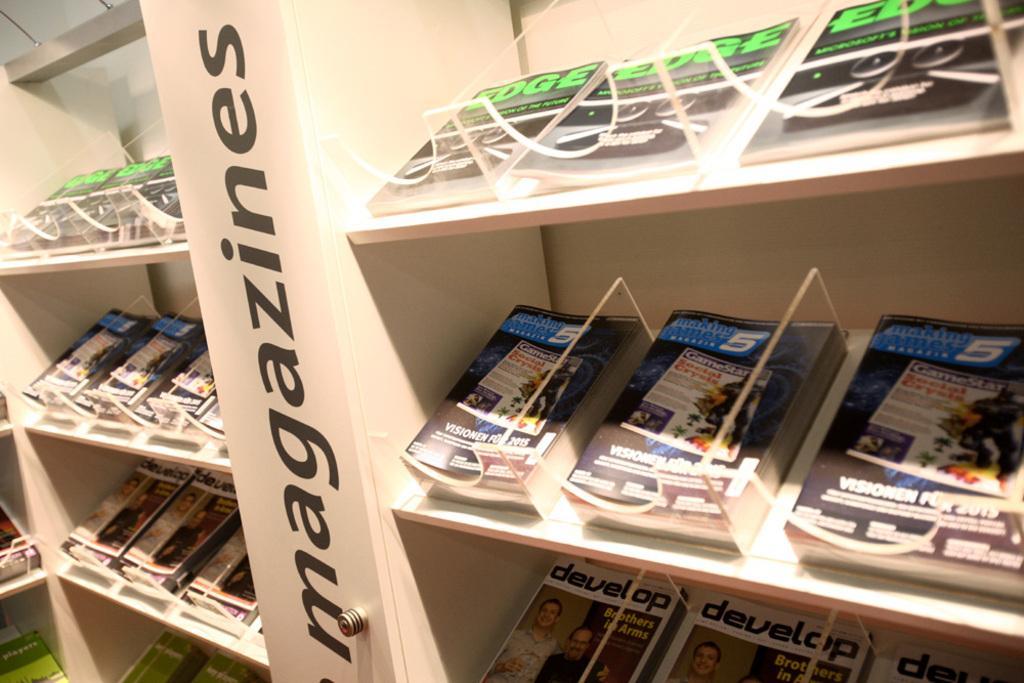Describe this image in one or two sentences. In this image there is a rack and we can see books placed in the rack. 